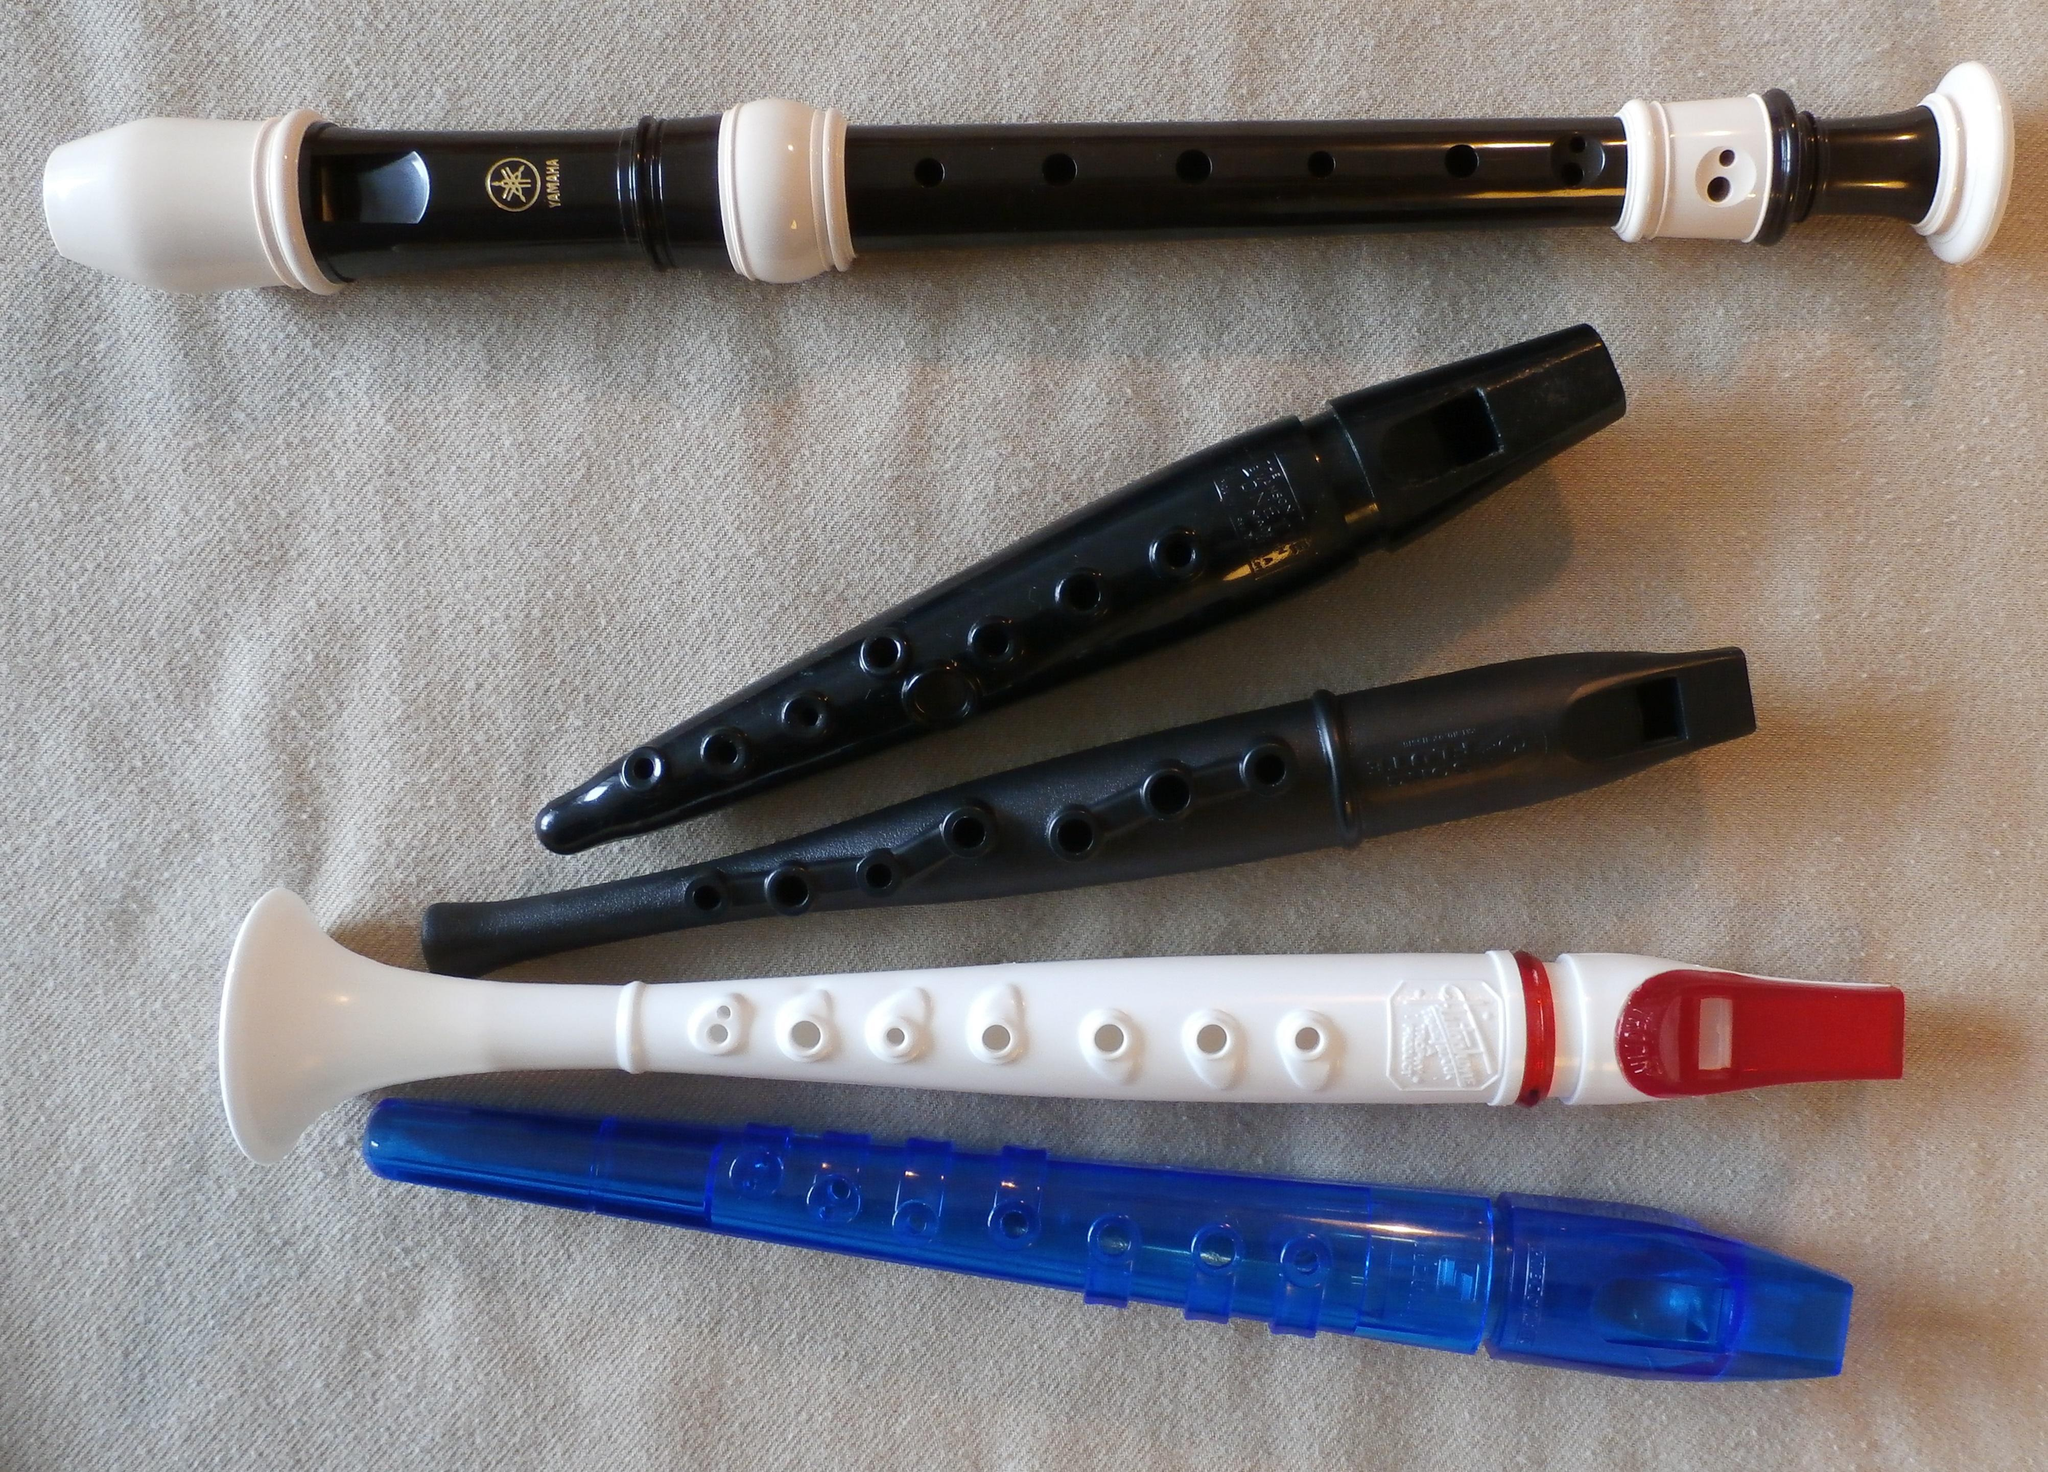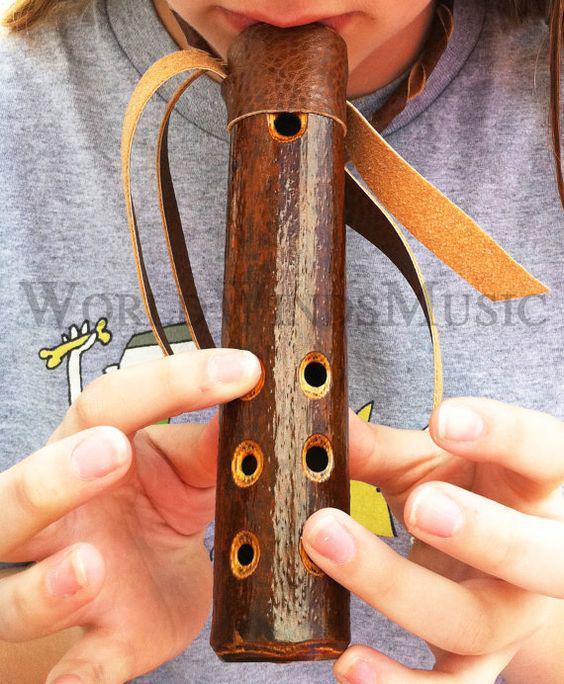The first image is the image on the left, the second image is the image on the right. For the images shown, is this caption "One of the images shows a two-piece flute, on a stand, apart." true? Answer yes or no. No. The first image is the image on the left, the second image is the image on the right. For the images displayed, is the sentence "Five wooden flutes are displayed horizontally on a stand." factually correct? Answer yes or no. No. 